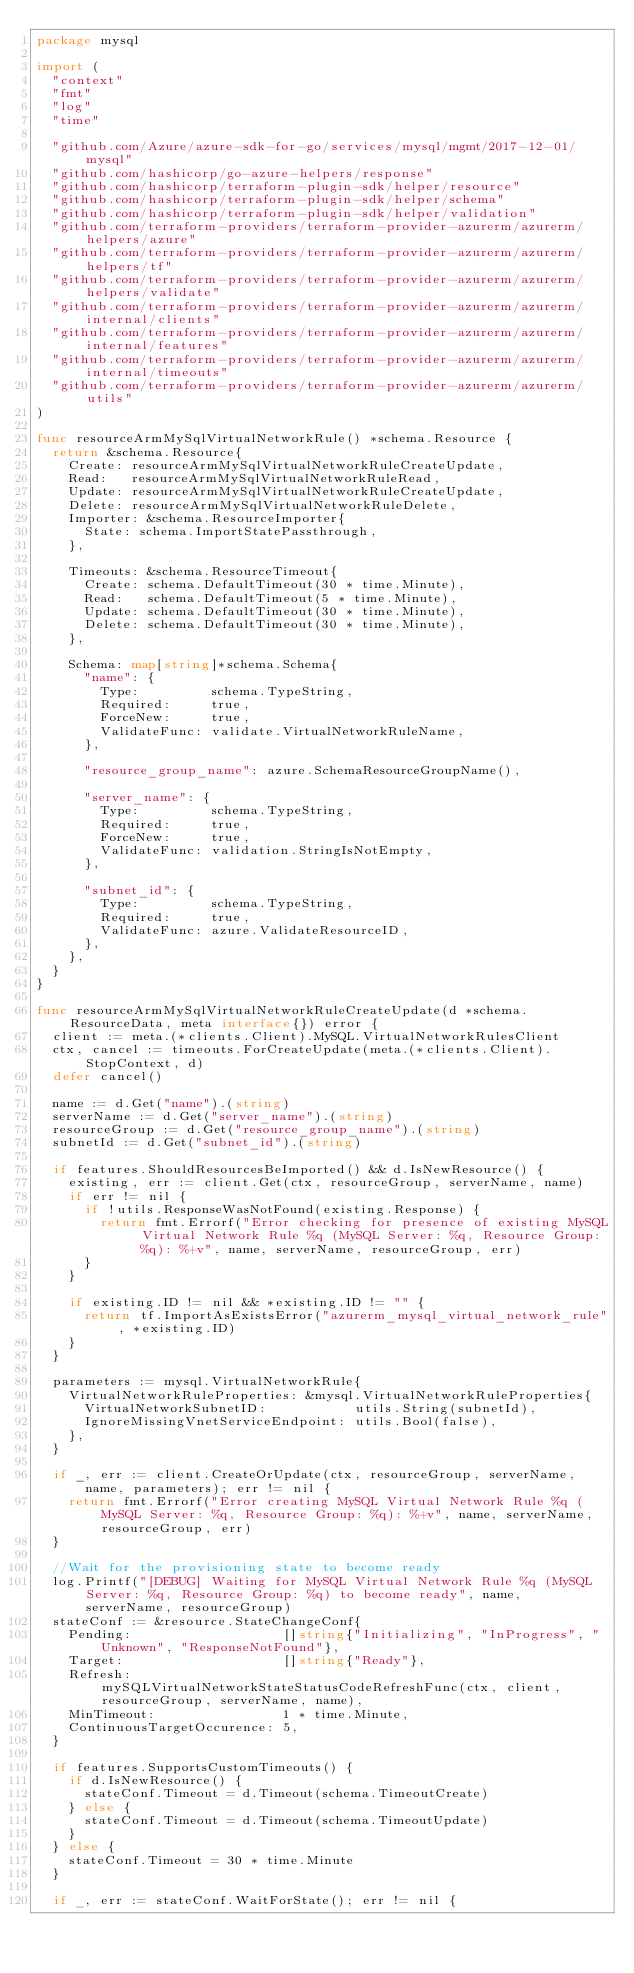<code> <loc_0><loc_0><loc_500><loc_500><_Go_>package mysql

import (
	"context"
	"fmt"
	"log"
	"time"

	"github.com/Azure/azure-sdk-for-go/services/mysql/mgmt/2017-12-01/mysql"
	"github.com/hashicorp/go-azure-helpers/response"
	"github.com/hashicorp/terraform-plugin-sdk/helper/resource"
	"github.com/hashicorp/terraform-plugin-sdk/helper/schema"
	"github.com/hashicorp/terraform-plugin-sdk/helper/validation"
	"github.com/terraform-providers/terraform-provider-azurerm/azurerm/helpers/azure"
	"github.com/terraform-providers/terraform-provider-azurerm/azurerm/helpers/tf"
	"github.com/terraform-providers/terraform-provider-azurerm/azurerm/helpers/validate"
	"github.com/terraform-providers/terraform-provider-azurerm/azurerm/internal/clients"
	"github.com/terraform-providers/terraform-provider-azurerm/azurerm/internal/features"
	"github.com/terraform-providers/terraform-provider-azurerm/azurerm/internal/timeouts"
	"github.com/terraform-providers/terraform-provider-azurerm/azurerm/utils"
)

func resourceArmMySqlVirtualNetworkRule() *schema.Resource {
	return &schema.Resource{
		Create: resourceArmMySqlVirtualNetworkRuleCreateUpdate,
		Read:   resourceArmMySqlVirtualNetworkRuleRead,
		Update: resourceArmMySqlVirtualNetworkRuleCreateUpdate,
		Delete: resourceArmMySqlVirtualNetworkRuleDelete,
		Importer: &schema.ResourceImporter{
			State: schema.ImportStatePassthrough,
		},

		Timeouts: &schema.ResourceTimeout{
			Create: schema.DefaultTimeout(30 * time.Minute),
			Read:   schema.DefaultTimeout(5 * time.Minute),
			Update: schema.DefaultTimeout(30 * time.Minute),
			Delete: schema.DefaultTimeout(30 * time.Minute),
		},

		Schema: map[string]*schema.Schema{
			"name": {
				Type:         schema.TypeString,
				Required:     true,
				ForceNew:     true,
				ValidateFunc: validate.VirtualNetworkRuleName,
			},

			"resource_group_name": azure.SchemaResourceGroupName(),

			"server_name": {
				Type:         schema.TypeString,
				Required:     true,
				ForceNew:     true,
				ValidateFunc: validation.StringIsNotEmpty,
			},

			"subnet_id": {
				Type:         schema.TypeString,
				Required:     true,
				ValidateFunc: azure.ValidateResourceID,
			},
		},
	}
}

func resourceArmMySqlVirtualNetworkRuleCreateUpdate(d *schema.ResourceData, meta interface{}) error {
	client := meta.(*clients.Client).MySQL.VirtualNetworkRulesClient
	ctx, cancel := timeouts.ForCreateUpdate(meta.(*clients.Client).StopContext, d)
	defer cancel()

	name := d.Get("name").(string)
	serverName := d.Get("server_name").(string)
	resourceGroup := d.Get("resource_group_name").(string)
	subnetId := d.Get("subnet_id").(string)

	if features.ShouldResourcesBeImported() && d.IsNewResource() {
		existing, err := client.Get(ctx, resourceGroup, serverName, name)
		if err != nil {
			if !utils.ResponseWasNotFound(existing.Response) {
				return fmt.Errorf("Error checking for presence of existing MySQL Virtual Network Rule %q (MySQL Server: %q, Resource Group: %q): %+v", name, serverName, resourceGroup, err)
			}
		}

		if existing.ID != nil && *existing.ID != "" {
			return tf.ImportAsExistsError("azurerm_mysql_virtual_network_rule", *existing.ID)
		}
	}

	parameters := mysql.VirtualNetworkRule{
		VirtualNetworkRuleProperties: &mysql.VirtualNetworkRuleProperties{
			VirtualNetworkSubnetID:           utils.String(subnetId),
			IgnoreMissingVnetServiceEndpoint: utils.Bool(false),
		},
	}

	if _, err := client.CreateOrUpdate(ctx, resourceGroup, serverName, name, parameters); err != nil {
		return fmt.Errorf("Error creating MySQL Virtual Network Rule %q (MySQL Server: %q, Resource Group: %q): %+v", name, serverName, resourceGroup, err)
	}

	//Wait for the provisioning state to become ready
	log.Printf("[DEBUG] Waiting for MySQL Virtual Network Rule %q (MySQL Server: %q, Resource Group: %q) to become ready", name, serverName, resourceGroup)
	stateConf := &resource.StateChangeConf{
		Pending:                   []string{"Initializing", "InProgress", "Unknown", "ResponseNotFound"},
		Target:                    []string{"Ready"},
		Refresh:                   mySQLVirtualNetworkStateStatusCodeRefreshFunc(ctx, client, resourceGroup, serverName, name),
		MinTimeout:                1 * time.Minute,
		ContinuousTargetOccurence: 5,
	}

	if features.SupportsCustomTimeouts() {
		if d.IsNewResource() {
			stateConf.Timeout = d.Timeout(schema.TimeoutCreate)
		} else {
			stateConf.Timeout = d.Timeout(schema.TimeoutUpdate)
		}
	} else {
		stateConf.Timeout = 30 * time.Minute
	}

	if _, err := stateConf.WaitForState(); err != nil {</code> 